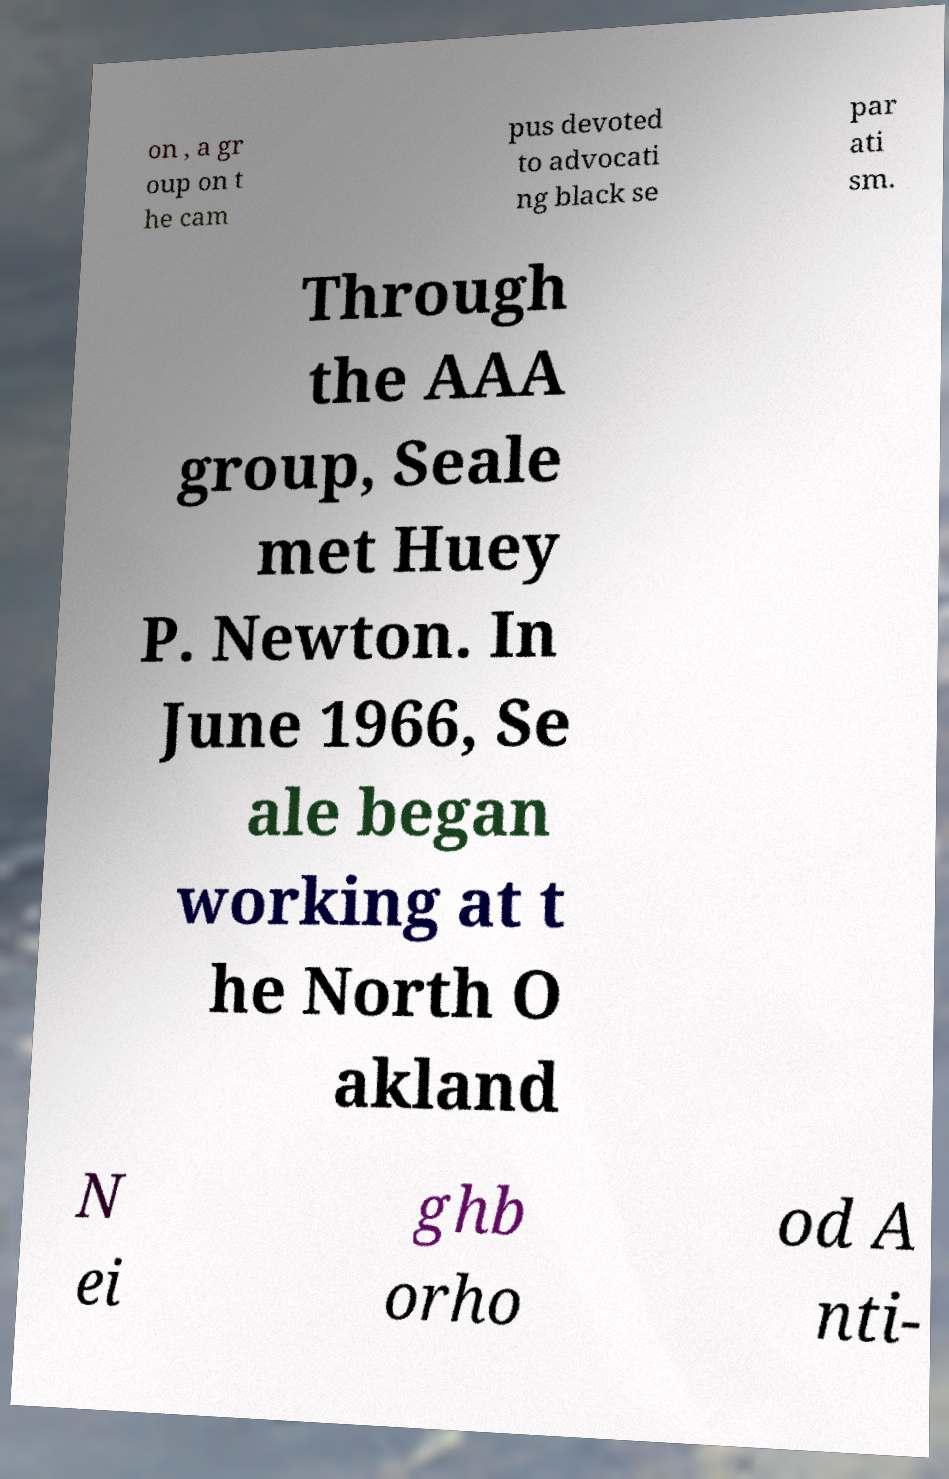For documentation purposes, I need the text within this image transcribed. Could you provide that? on , a gr oup on t he cam pus devoted to advocati ng black se par ati sm. Through the AAA group, Seale met Huey P. Newton. In June 1966, Se ale began working at t he North O akland N ei ghb orho od A nti- 